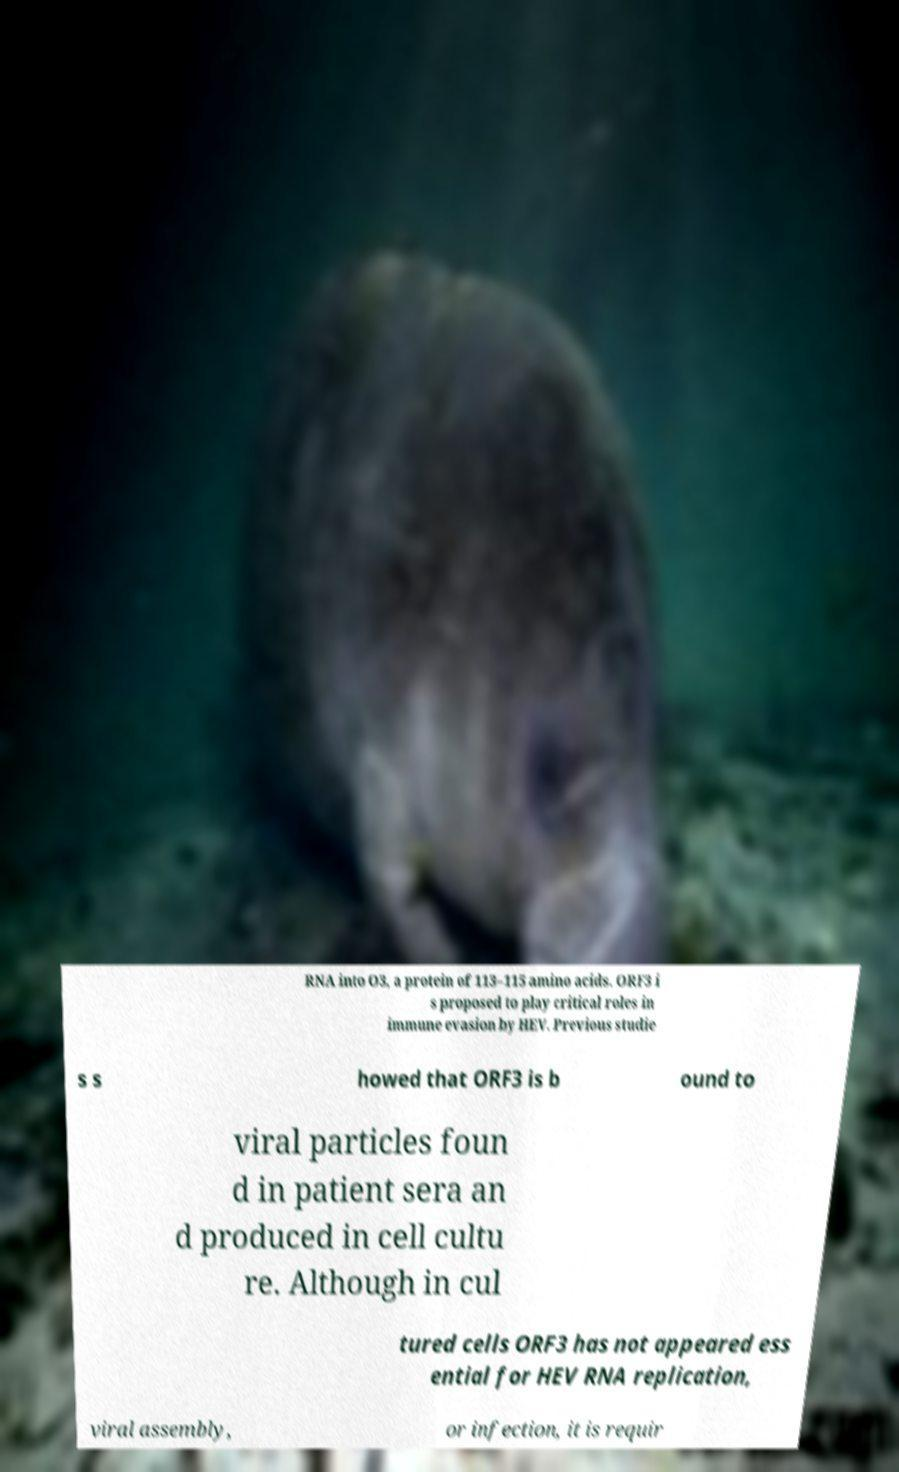Please identify and transcribe the text found in this image. RNA into O3, a protein of 113–115 amino acids. ORF3 i s proposed to play critical roles in immune evasion by HEV. Previous studie s s howed that ORF3 is b ound to viral particles foun d in patient sera an d produced in cell cultu re. Although in cul tured cells ORF3 has not appeared ess ential for HEV RNA replication, viral assembly, or infection, it is requir 